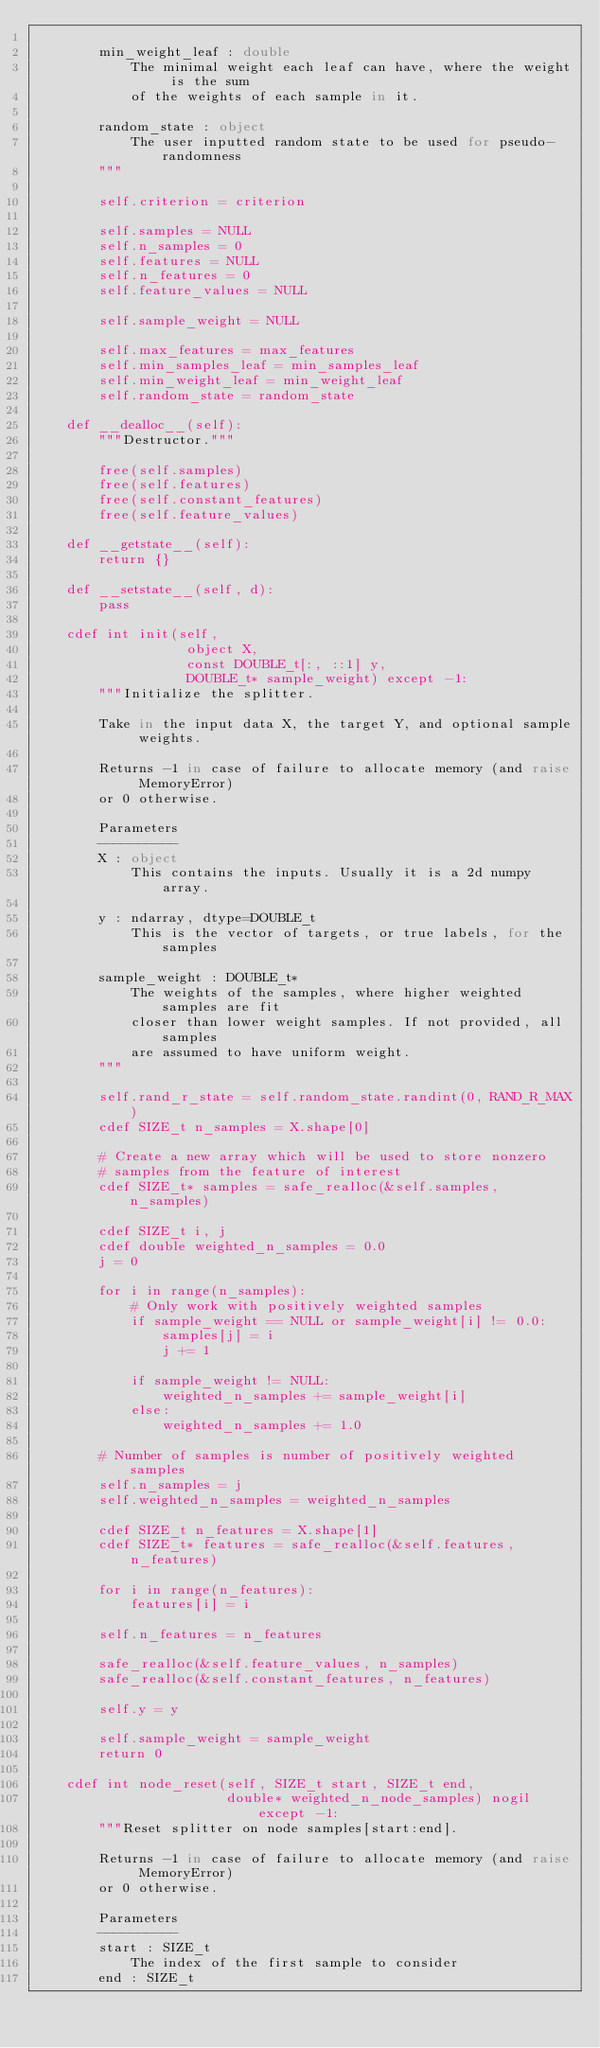Convert code to text. <code><loc_0><loc_0><loc_500><loc_500><_Cython_>
        min_weight_leaf : double
            The minimal weight each leaf can have, where the weight is the sum
            of the weights of each sample in it.

        random_state : object
            The user inputted random state to be used for pseudo-randomness
        """

        self.criterion = criterion

        self.samples = NULL
        self.n_samples = 0
        self.features = NULL
        self.n_features = 0
        self.feature_values = NULL

        self.sample_weight = NULL

        self.max_features = max_features
        self.min_samples_leaf = min_samples_leaf
        self.min_weight_leaf = min_weight_leaf
        self.random_state = random_state

    def __dealloc__(self):
        """Destructor."""

        free(self.samples)
        free(self.features)
        free(self.constant_features)
        free(self.feature_values)

    def __getstate__(self):
        return {}

    def __setstate__(self, d):
        pass

    cdef int init(self,
                   object X,
                   const DOUBLE_t[:, ::1] y,
                   DOUBLE_t* sample_weight) except -1:
        """Initialize the splitter.

        Take in the input data X, the target Y, and optional sample weights.

        Returns -1 in case of failure to allocate memory (and raise MemoryError)
        or 0 otherwise.

        Parameters
        ----------
        X : object
            This contains the inputs. Usually it is a 2d numpy array.

        y : ndarray, dtype=DOUBLE_t
            This is the vector of targets, or true labels, for the samples

        sample_weight : DOUBLE_t*
            The weights of the samples, where higher weighted samples are fit
            closer than lower weight samples. If not provided, all samples
            are assumed to have uniform weight.
        """

        self.rand_r_state = self.random_state.randint(0, RAND_R_MAX)
        cdef SIZE_t n_samples = X.shape[0]

        # Create a new array which will be used to store nonzero
        # samples from the feature of interest
        cdef SIZE_t* samples = safe_realloc(&self.samples, n_samples)

        cdef SIZE_t i, j
        cdef double weighted_n_samples = 0.0
        j = 0

        for i in range(n_samples):
            # Only work with positively weighted samples
            if sample_weight == NULL or sample_weight[i] != 0.0:
                samples[j] = i
                j += 1

            if sample_weight != NULL:
                weighted_n_samples += sample_weight[i]
            else:
                weighted_n_samples += 1.0

        # Number of samples is number of positively weighted samples
        self.n_samples = j
        self.weighted_n_samples = weighted_n_samples

        cdef SIZE_t n_features = X.shape[1]
        cdef SIZE_t* features = safe_realloc(&self.features, n_features)

        for i in range(n_features):
            features[i] = i

        self.n_features = n_features

        safe_realloc(&self.feature_values, n_samples)
        safe_realloc(&self.constant_features, n_features)

        self.y = y

        self.sample_weight = sample_weight
        return 0

    cdef int node_reset(self, SIZE_t start, SIZE_t end,
                        double* weighted_n_node_samples) nogil except -1:
        """Reset splitter on node samples[start:end].

        Returns -1 in case of failure to allocate memory (and raise MemoryError)
        or 0 otherwise.

        Parameters
        ----------
        start : SIZE_t
            The index of the first sample to consider
        end : SIZE_t</code> 